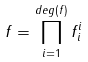<formula> <loc_0><loc_0><loc_500><loc_500>f = \prod _ { i = 1 } ^ { d e g ( f ) } f _ { i } ^ { i }</formula> 